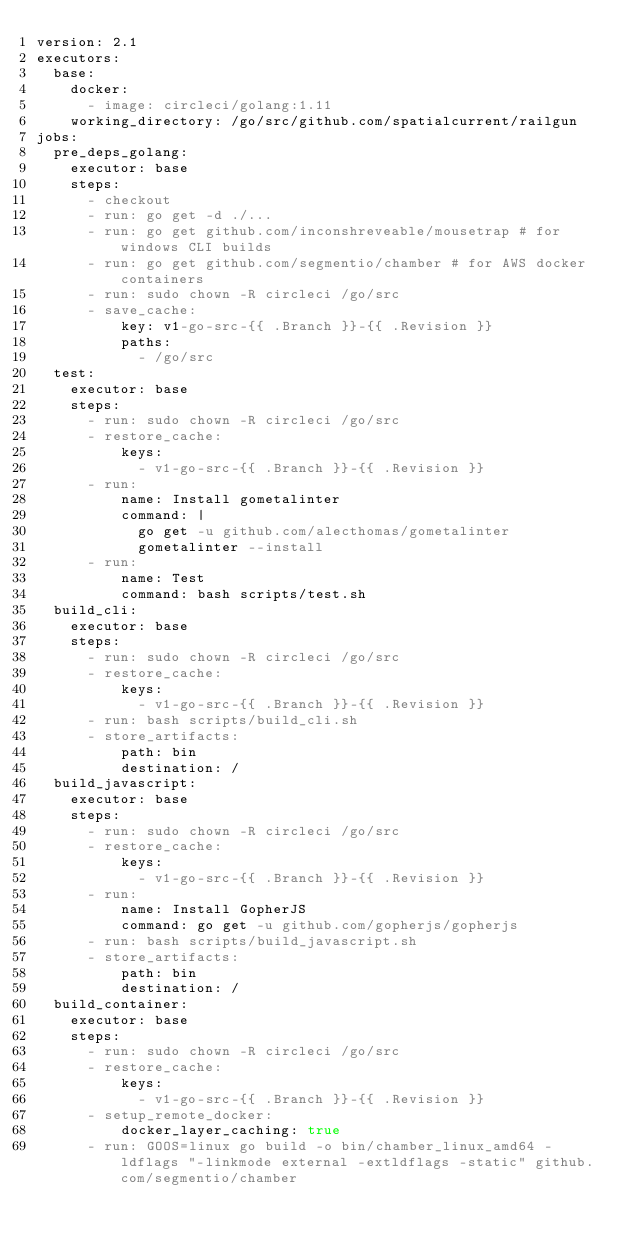<code> <loc_0><loc_0><loc_500><loc_500><_YAML_>version: 2.1
executors:
  base:
    docker:
      - image: circleci/golang:1.11
    working_directory: /go/src/github.com/spatialcurrent/railgun
jobs:
  pre_deps_golang:
    executor: base
    steps:
      - checkout
      - run: go get -d ./...
      - run: go get github.com/inconshreveable/mousetrap # for windows CLI builds
      - run: go get github.com/segmentio/chamber # for AWS docker containers
      - run: sudo chown -R circleci /go/src
      - save_cache:
          key: v1-go-src-{{ .Branch }}-{{ .Revision }}
          paths:
            - /go/src
  test:
    executor: base
    steps:
      - run: sudo chown -R circleci /go/src
      - restore_cache:
          keys:
            - v1-go-src-{{ .Branch }}-{{ .Revision }}
      - run:
          name: Install gometalinter
          command: |
            go get -u github.com/alecthomas/gometalinter
            gometalinter --install
      - run:
          name: Test
          command: bash scripts/test.sh
  build_cli:
    executor: base
    steps:
      - run: sudo chown -R circleci /go/src
      - restore_cache:
          keys:
            - v1-go-src-{{ .Branch }}-{{ .Revision }}
      - run: bash scripts/build_cli.sh
      - store_artifacts:
          path: bin
          destination: /
  build_javascript:
    executor: base
    steps:
      - run: sudo chown -R circleci /go/src
      - restore_cache:
          keys:
            - v1-go-src-{{ .Branch }}-{{ .Revision }}
      - run:
          name: Install GopherJS
          command: go get -u github.com/gopherjs/gopherjs
      - run: bash scripts/build_javascript.sh
      - store_artifacts:
          path: bin
          destination: /
  build_container:
    executor: base
    steps:
      - run: sudo chown -R circleci /go/src
      - restore_cache:
          keys:
            - v1-go-src-{{ .Branch }}-{{ .Revision }}
      - setup_remote_docker:
          docker_layer_caching: true
      - run: GOOS=linux go build -o bin/chamber_linux_amd64 -ldflags "-linkmode external -extldflags -static" github.com/segmentio/chamber</code> 